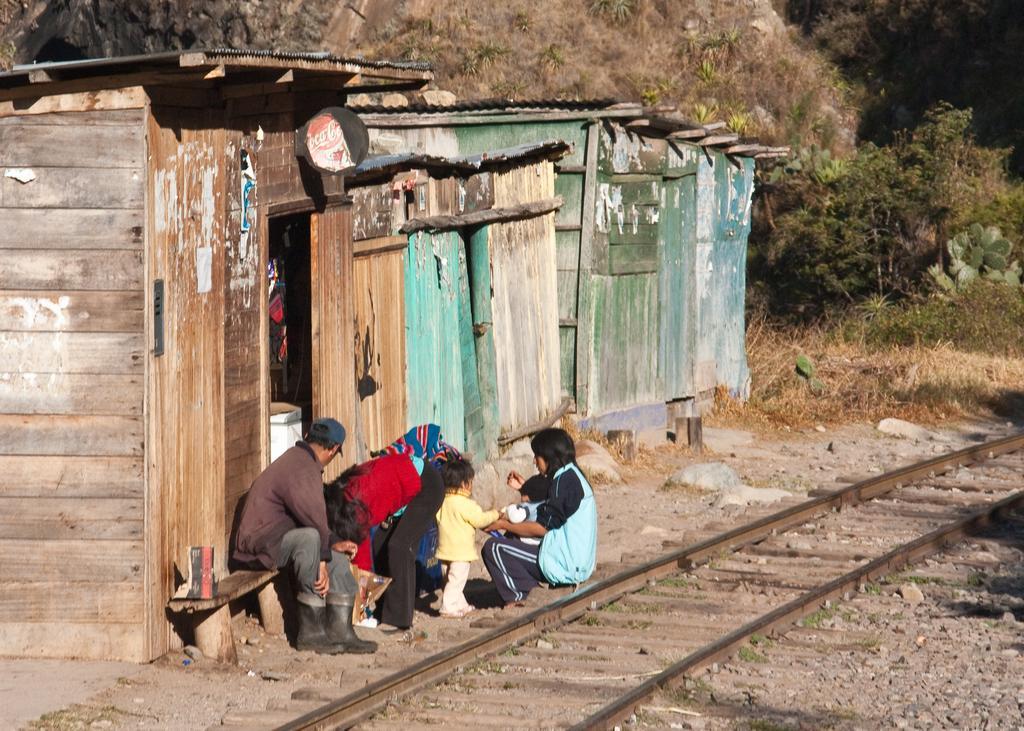How would you summarize this image in a sentence or two? In this picture we can see some people on the ground, railway track, bench, stones, plants, sheds and some objects and in the background we can see trees. 